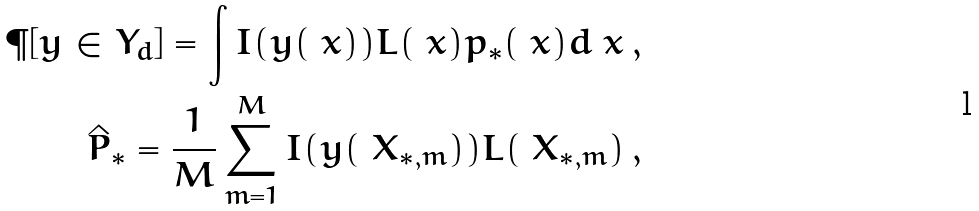<formula> <loc_0><loc_0><loc_500><loc_500>\P [ y \in Y _ { d } ] = \int I ( y ( \ x ) ) L ( \ x ) p _ { * } ( \ x ) d \ x \, , \\ \hat { P } _ { * } = \frac { 1 } { M } \sum _ { m = 1 } ^ { M } I ( y ( \ X _ { * , m } ) ) L ( \ X _ { * , m } ) \, ,</formula> 